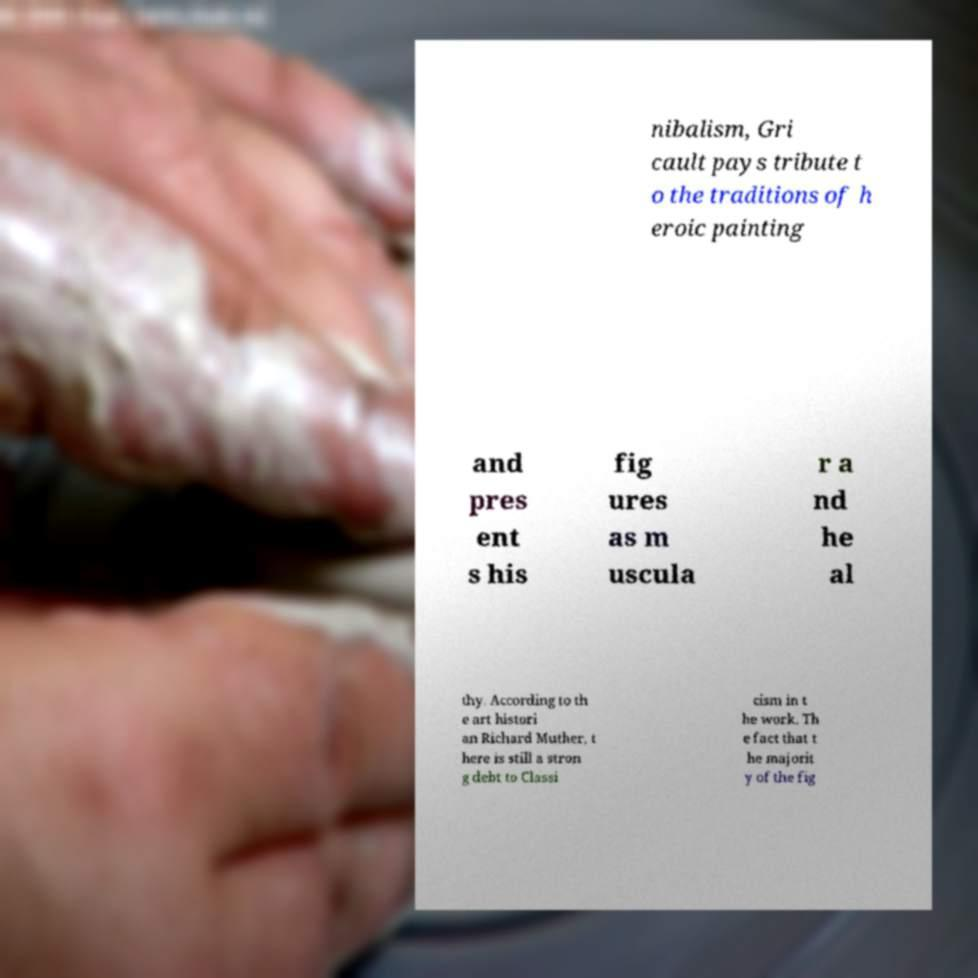Please read and relay the text visible in this image. What does it say? nibalism, Gri cault pays tribute t o the traditions of h eroic painting and pres ent s his fig ures as m uscula r a nd he al thy. According to th e art histori an Richard Muther, t here is still a stron g debt to Classi cism in t he work. Th e fact that t he majorit y of the fig 